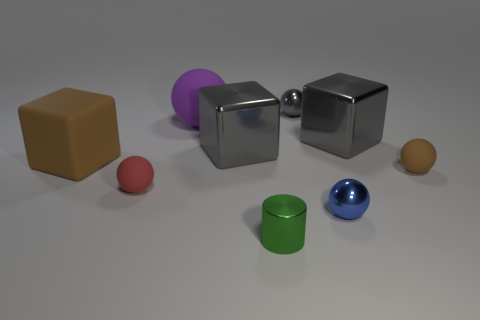Are there any patterns or textures on the objects? No, the objects do not display any visible patterns or textures; each exhibits a smooth and uniform surface. 